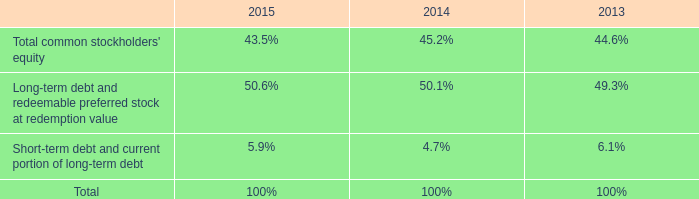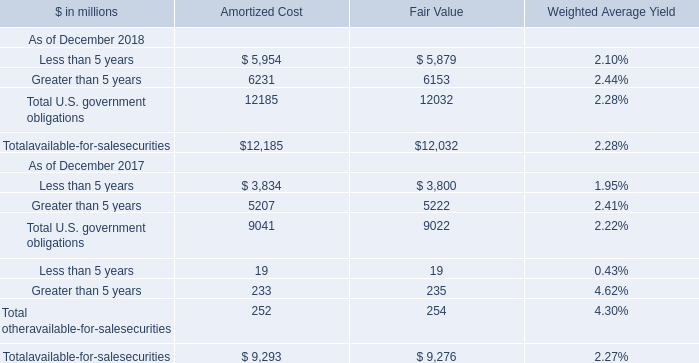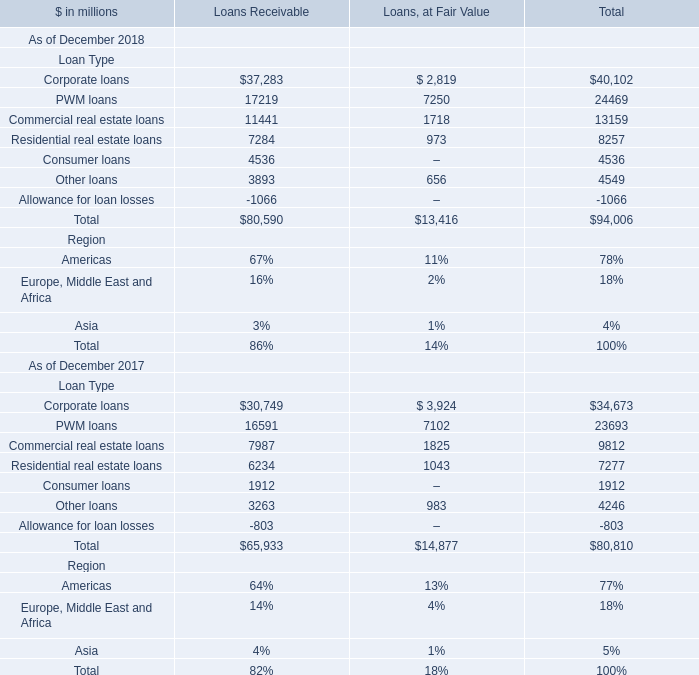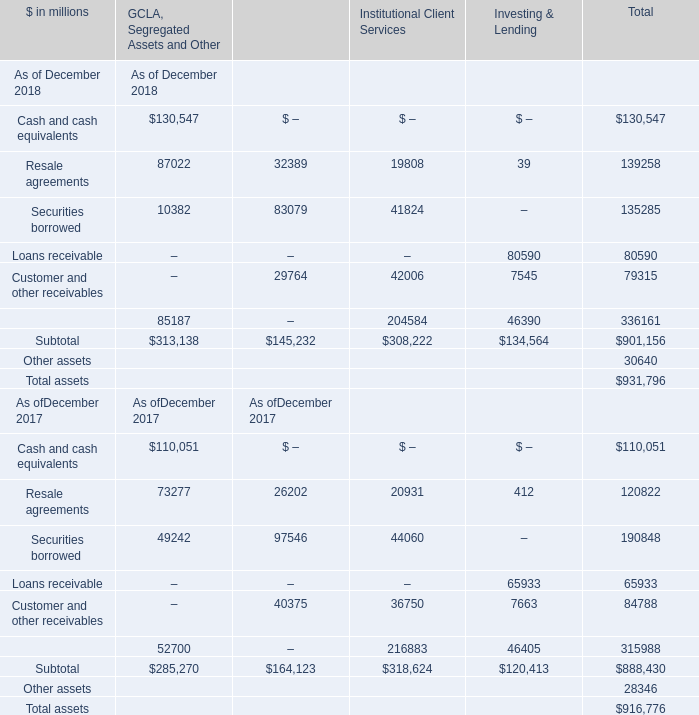In the year with largest amount of Corporate loans, what's the increasing rate of Allowance for loan losses? 
Computations: ((-1066 + 803) / -1066)
Answer: 0.24672. 